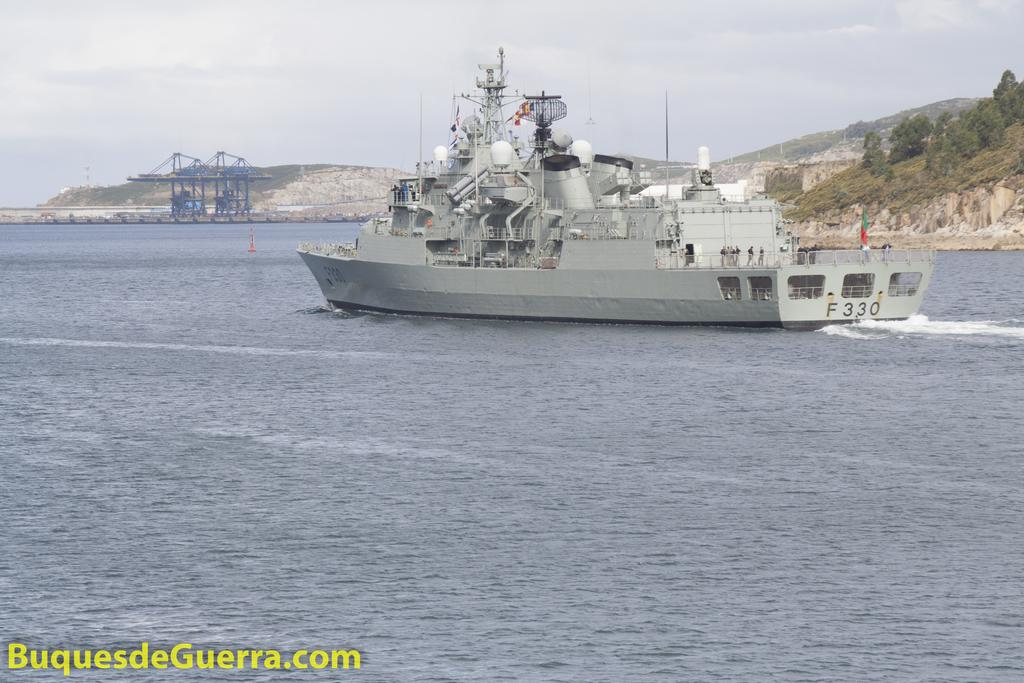<image>
Render a clear and concise summary of the photo. a gray ship with the number F330 listed on the back 